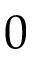Convert formula to latex. <formula><loc_0><loc_0><loc_500><loc_500>0</formula> 